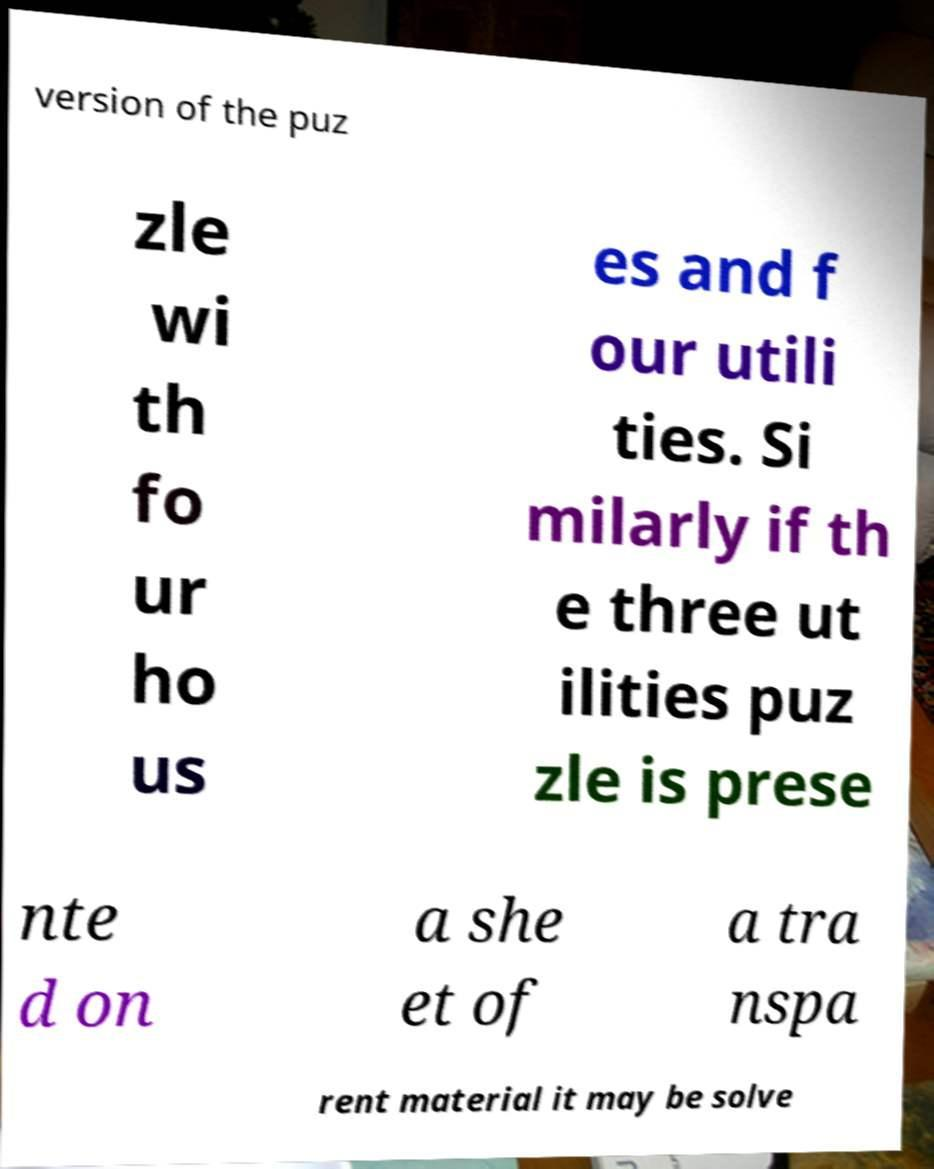Please identify and transcribe the text found in this image. version of the puz zle wi th fo ur ho us es and f our utili ties. Si milarly if th e three ut ilities puz zle is prese nte d on a she et of a tra nspa rent material it may be solve 